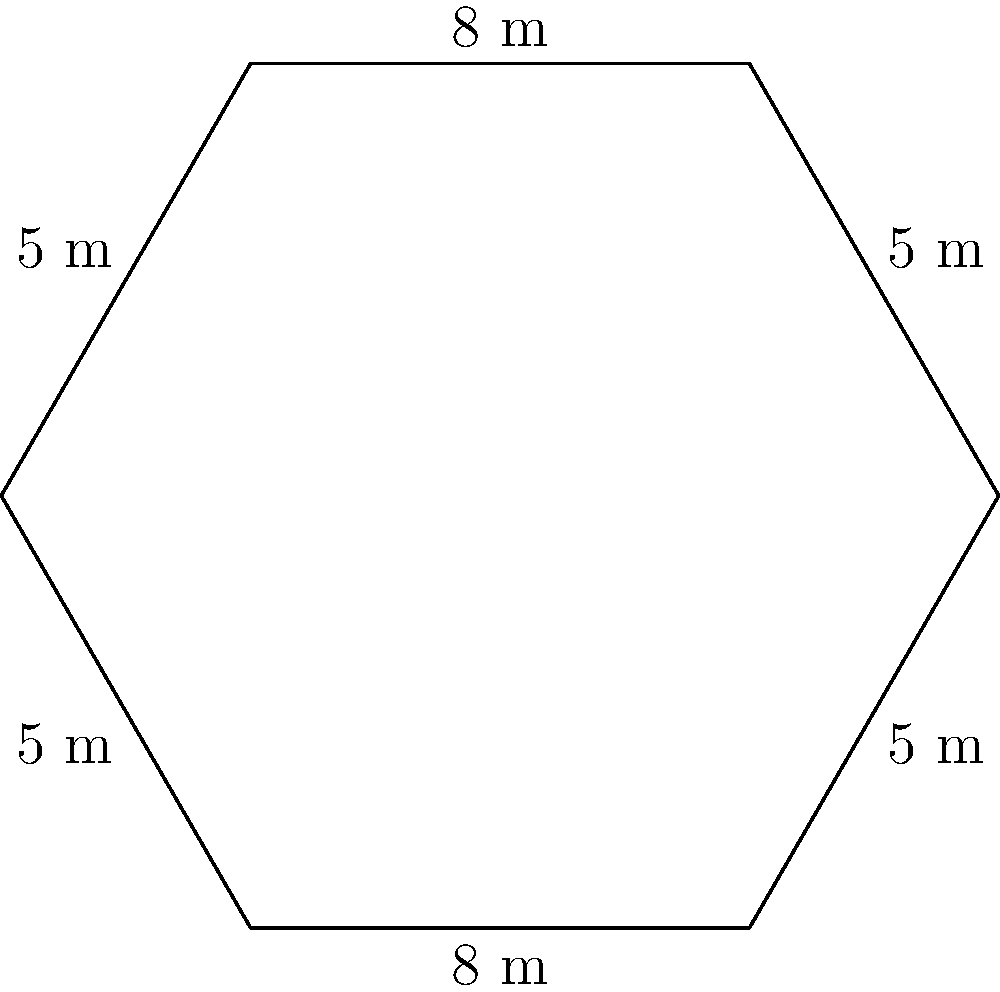You're helping a homeowner design a hexagonal garden plot. They want to fence it and need to know how much fencing material to buy. The garden has alternating sides of 8 meters and 5 meters, as shown in the diagram. What is the total perimeter of the garden plot? To find the perimeter of the hexagonal garden plot, we need to add up the lengths of all sides. Let's break it down step-by-step:

1. Identify the lengths of the sides:
   - There are two sides with length 8 meters
   - There are four sides with length 5 meters

2. Calculate the sum of all sides:
   $$(2 \times 8 \text{ m}) + (4 \times 5 \text{ m})$$

3. Simplify the calculation:
   $$16 \text{ m} + 20 \text{ m} = 36 \text{ m}$$

Therefore, the total perimeter of the hexagonal garden plot is 36 meters.
Answer: 36 m 